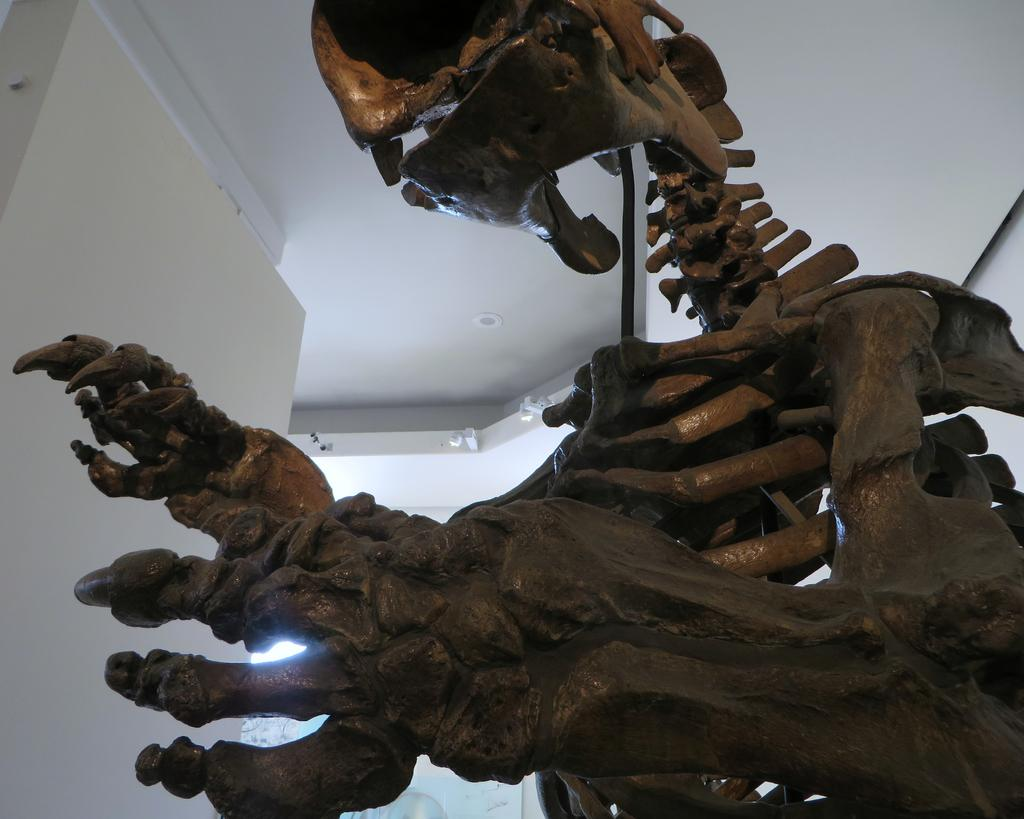What is the main subject of the image? The main subject of the image is a skeleton of a dinosaur. What else can be seen in the image? There is a wall in the image. What type of song is being sung by the dinosaur in the image? There is no indication in the image that the dinosaur is singing a song, as it is a skeleton and not a living creature. 